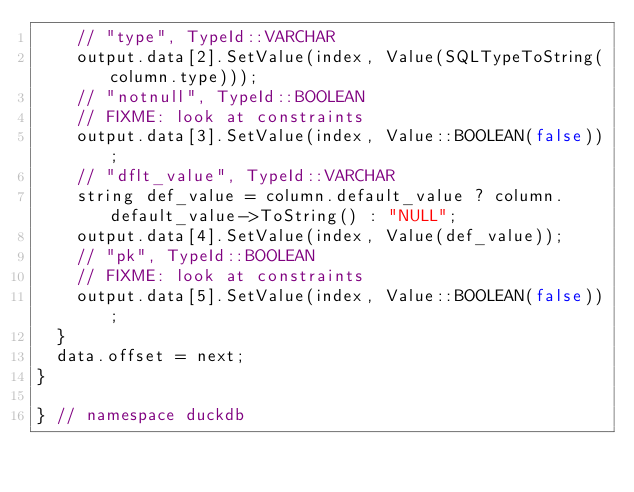<code> <loc_0><loc_0><loc_500><loc_500><_C++_>		// "type", TypeId::VARCHAR
		output.data[2].SetValue(index, Value(SQLTypeToString(column.type)));
		// "notnull", TypeId::BOOLEAN
		// FIXME: look at constraints
		output.data[3].SetValue(index, Value::BOOLEAN(false));
		// "dflt_value", TypeId::VARCHAR
		string def_value = column.default_value ? column.default_value->ToString() : "NULL";
		output.data[4].SetValue(index, Value(def_value));
		// "pk", TypeId::BOOLEAN
		// FIXME: look at constraints
		output.data[5].SetValue(index, Value::BOOLEAN(false));
	}
	data.offset = next;
}

} // namespace duckdb
</code> 